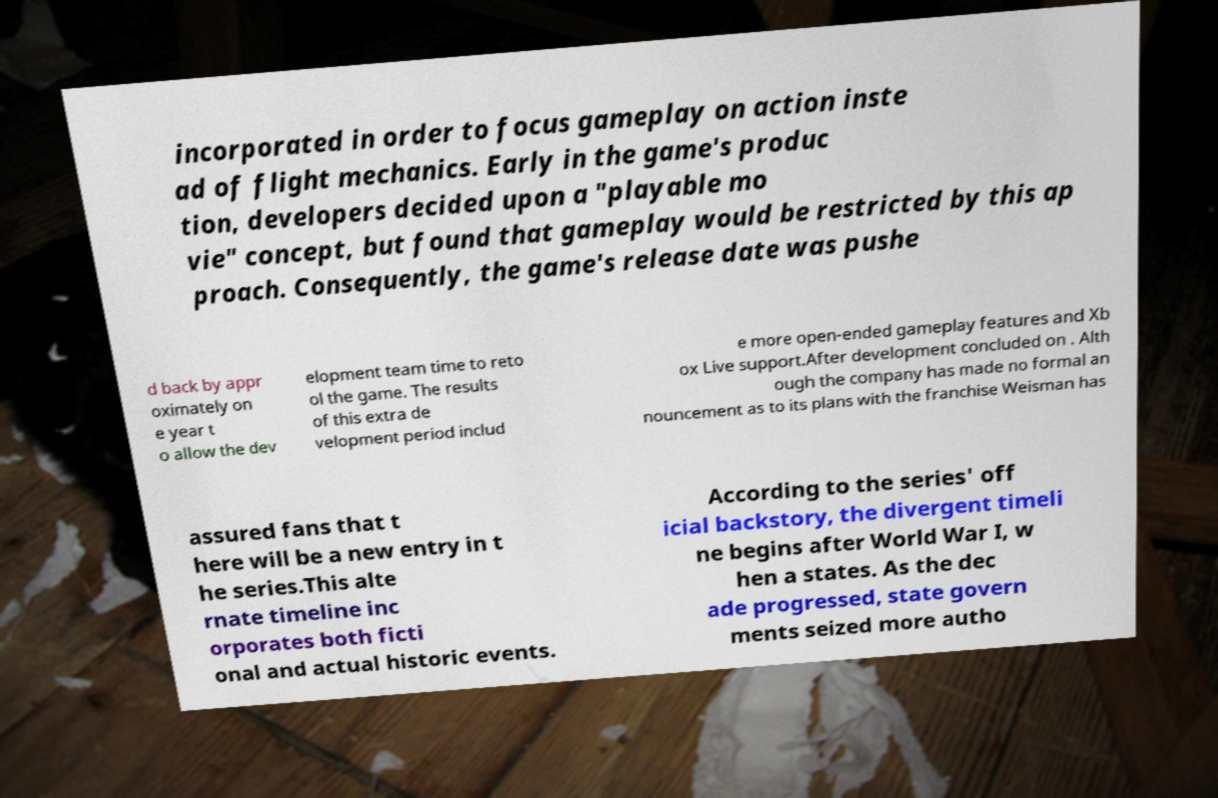Please identify and transcribe the text found in this image. incorporated in order to focus gameplay on action inste ad of flight mechanics. Early in the game's produc tion, developers decided upon a "playable mo vie" concept, but found that gameplay would be restricted by this ap proach. Consequently, the game's release date was pushe d back by appr oximately on e year t o allow the dev elopment team time to reto ol the game. The results of this extra de velopment period includ e more open-ended gameplay features and Xb ox Live support.After development concluded on . Alth ough the company has made no formal an nouncement as to its plans with the franchise Weisman has assured fans that t here will be a new entry in t he series.This alte rnate timeline inc orporates both ficti onal and actual historic events. According to the series' off icial backstory, the divergent timeli ne begins after World War I, w hen a states. As the dec ade progressed, state govern ments seized more autho 